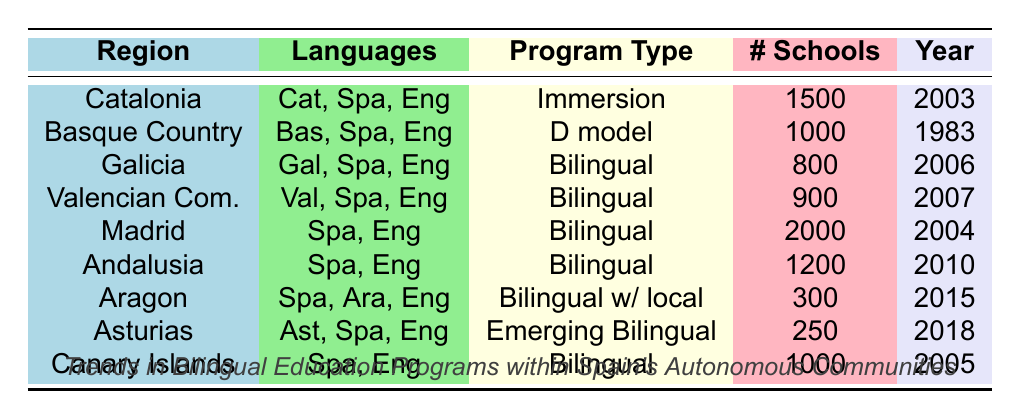What is the program type implemented in Catalonia? The table shows that the program type in Catalonia is "Immersion". This can be directly retrieved from the corresponding row under the "Program Type" column.
Answer: Immersion How many schools in the Valencian Community offer bilingual education programs? Referring to the table, the number of schools in the Valencian Community is listed as 900 under the "# Schools" column.
Answer: 900 Which region has the lowest number of schools participating in bilingual education? By examining the "# Schools" column, Asturias shows the lowest number of schools at 250. Comparing it with other regions confirms this.
Answer: Asturias Is the Basque Country's bilingual program based on the D model? The table explicitly states that the Basque Country has a program type labeled "D model". This provides a straightforward yes answer to the question.
Answer: Yes What is the sum of schools offering bilingual programs in Madrid and Andalusia? To find this, we take the number of schools: 2000 (Madrid) + 1200 (Andalusia) = 3200. This involves retrieving data from the respective rows and then performing a simple addition.
Answer: 3200 Which two regions implemented their bilingual education programs most recently? The years of implementation in the table indicate that Asturias (2018) and Aragon (2015) are the most recent. By comparing the years listed, these two stand out.
Answer: Asturias and Aragon Are there any regions implementing bilingual programs that include a local language? Only Aragon, which has a program type labeled "Bilingual with local language," meets this criteria based on the table content.
Answer: Yes What is the average number of schools participating in bilingual education programs across all regions? First, we sum the number of schools from all regions: 1500 + 1000 + 800 + 900 + 2000 + 1200 + 300 + 250 + 1000 = 6150. Next, we divide by the number of regions (9) to get the average: 6150 / 9 = 683.33, which we can round to 683 for simplicity.
Answer: 683 How many regions are implementing bilingual education programs since the year 2000? The regions that implemented programs since 2000 are Catalonia (2003), Madrid (2004), Canary Islands (2005), Galicia (2006), Valencian Community (2007), and Andalusia (2010). Counting these gives us a total of 6 regions that meet this criterion.
Answer: 6 